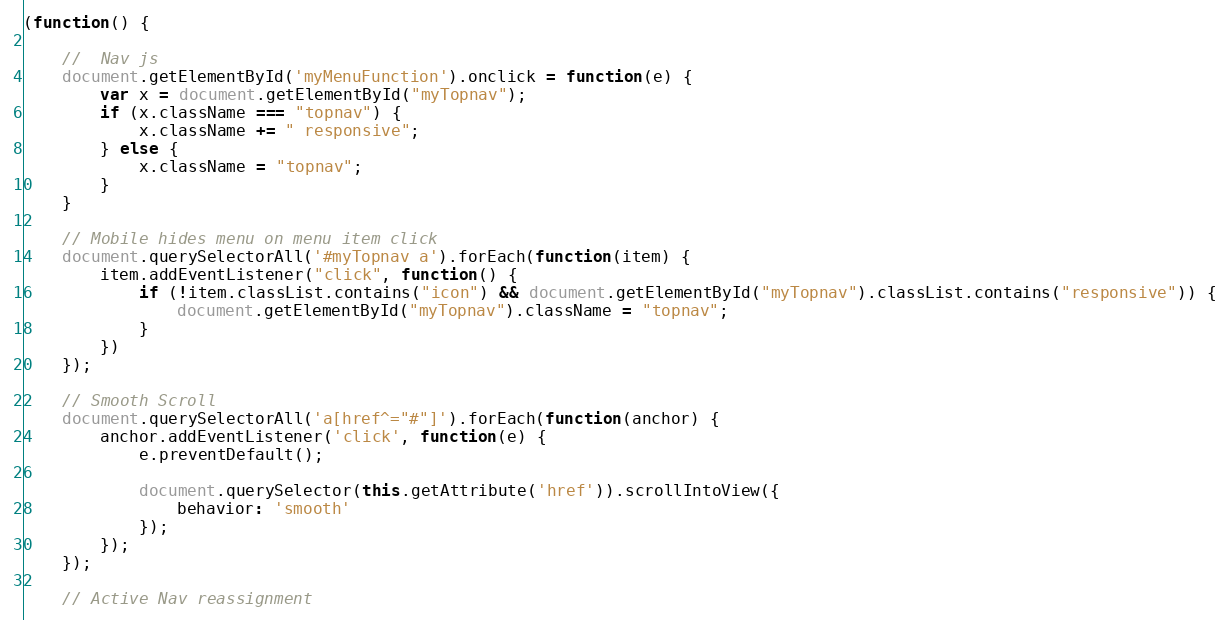Convert code to text. <code><loc_0><loc_0><loc_500><loc_500><_JavaScript_>(function() {

    //  Nav js
    document.getElementById('myMenuFunction').onclick = function(e) {
        var x = document.getElementById("myTopnav");
        if (x.className === "topnav") {
            x.className += " responsive";
        } else {
            x.className = "topnav";
        }
    }

    // Mobile hides menu on menu item click
    document.querySelectorAll('#myTopnav a').forEach(function(item) {
        item.addEventListener("click", function() {
            if (!item.classList.contains("icon") && document.getElementById("myTopnav").classList.contains("responsive")) {
                document.getElementById("myTopnav").className = "topnav";
            }
        })
    });

    // Smooth Scroll
    document.querySelectorAll('a[href^="#"]').forEach(function(anchor) {
        anchor.addEventListener('click', function(e) {
            e.preventDefault();

            document.querySelector(this.getAttribute('href')).scrollIntoView({
                behavior: 'smooth'
            });
        });
    });

    // Active Nav reassignment
</code> 